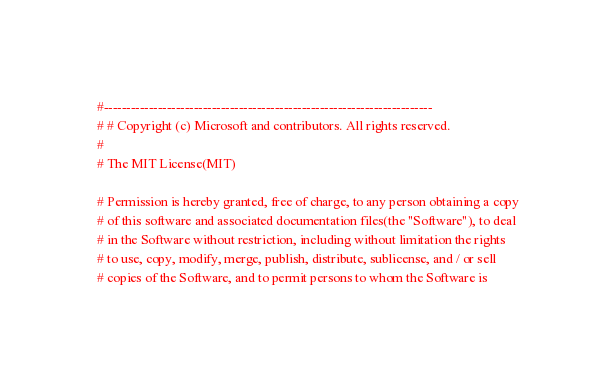<code> <loc_0><loc_0><loc_500><loc_500><_Ruby_>#-------------------------------------------------------------------------
# # Copyright (c) Microsoft and contributors. All rights reserved.
#
# The MIT License(MIT)

# Permission is hereby granted, free of charge, to any person obtaining a copy
# of this software and associated documentation files(the "Software"), to deal
# in the Software without restriction, including without limitation the rights
# to use, copy, modify, merge, publish, distribute, sublicense, and / or sell
# copies of the Software, and to permit persons to whom the Software is</code> 